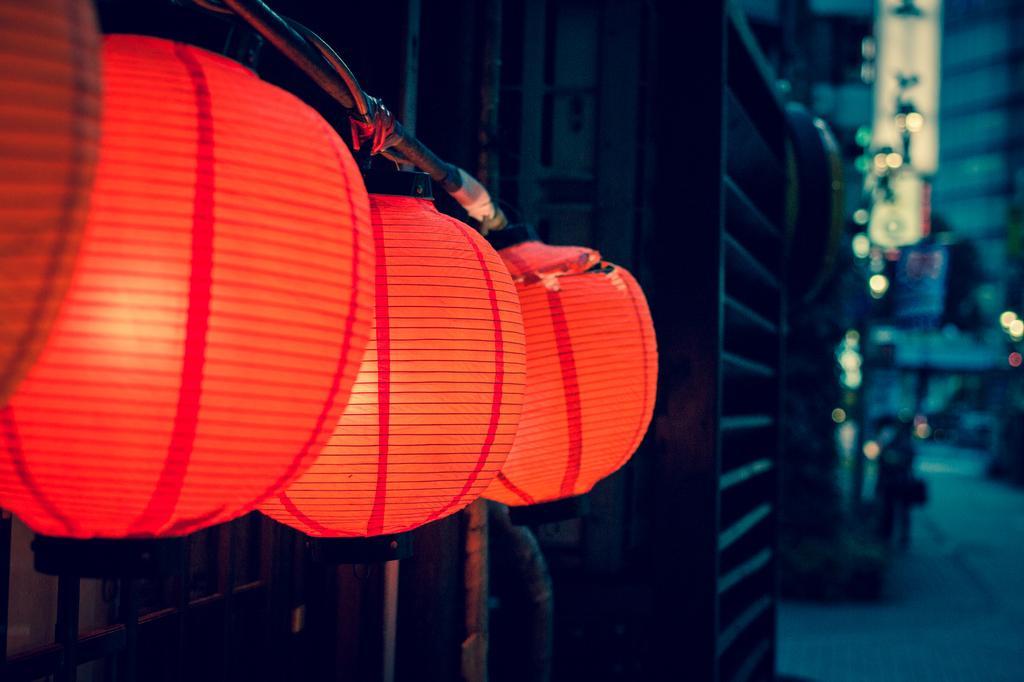Can you describe this image briefly? In this image there are a few balloons with lights are hanging on the road, beside that there is a metal structure and there is a person standing on the road. The background is blurred. 